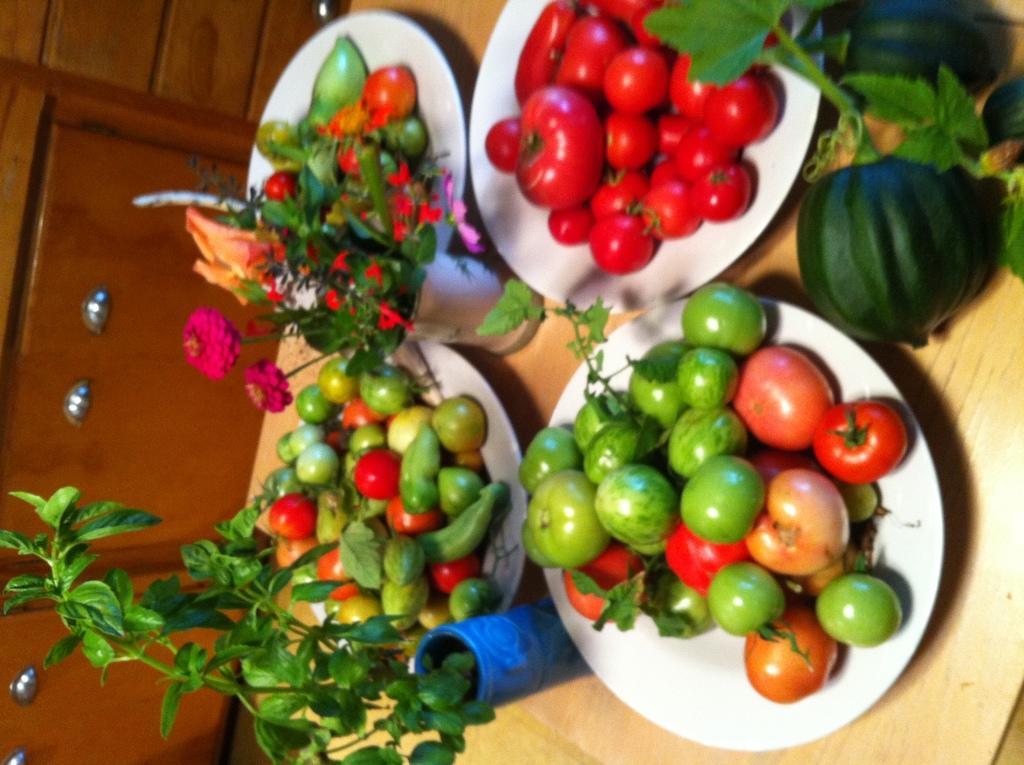Could you give a brief overview of what you see in this image? In this image at the bottom there is one table, on the table there are some plates and in the plates there are some tomatoes, brinjals and some vegetables. And also there are some flower pots and plants and flowers, on the left side there is one wooden cupboard. 